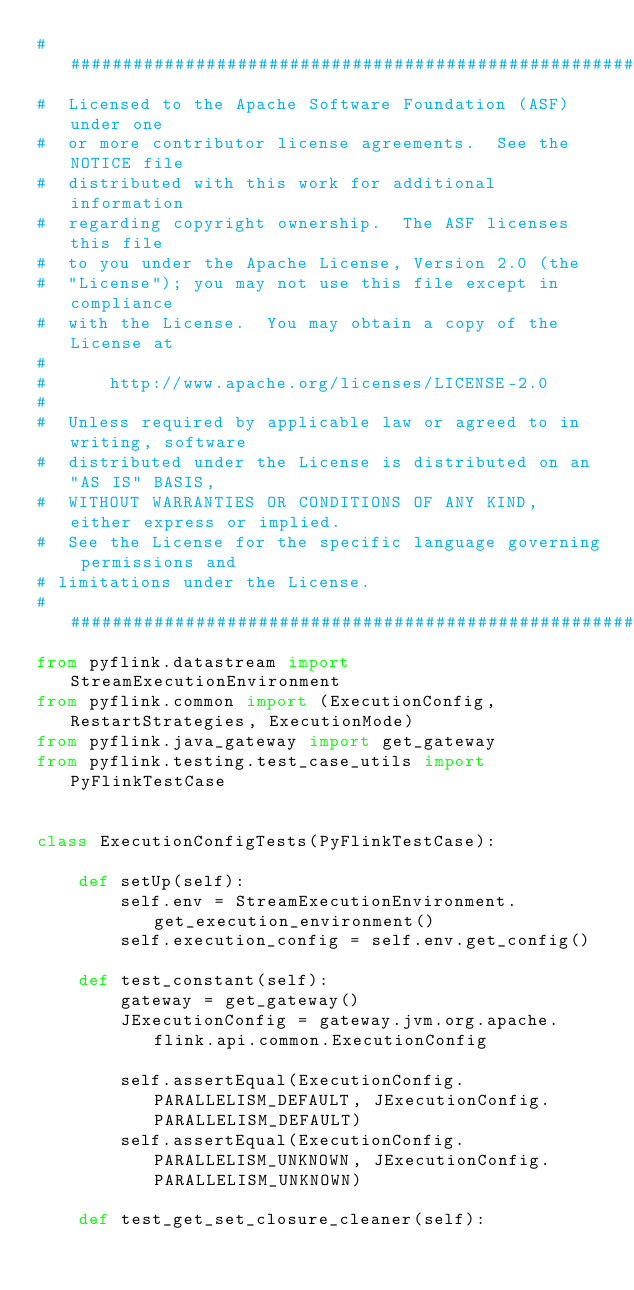Convert code to text. <code><loc_0><loc_0><loc_500><loc_500><_Python_>################################################################################
#  Licensed to the Apache Software Foundation (ASF) under one
#  or more contributor license agreements.  See the NOTICE file
#  distributed with this work for additional information
#  regarding copyright ownership.  The ASF licenses this file
#  to you under the Apache License, Version 2.0 (the
#  "License"); you may not use this file except in compliance
#  with the License.  You may obtain a copy of the License at
#
#      http://www.apache.org/licenses/LICENSE-2.0
#
#  Unless required by applicable law or agreed to in writing, software
#  distributed under the License is distributed on an "AS IS" BASIS,
#  WITHOUT WARRANTIES OR CONDITIONS OF ANY KIND, either express or implied.
#  See the License for the specific language governing permissions and
# limitations under the License.
################################################################################
from pyflink.datastream import StreamExecutionEnvironment
from pyflink.common import (ExecutionConfig, RestartStrategies, ExecutionMode)
from pyflink.java_gateway import get_gateway
from pyflink.testing.test_case_utils import PyFlinkTestCase


class ExecutionConfigTests(PyFlinkTestCase):

    def setUp(self):
        self.env = StreamExecutionEnvironment.get_execution_environment()
        self.execution_config = self.env.get_config()

    def test_constant(self):
        gateway = get_gateway()
        JExecutionConfig = gateway.jvm.org.apache.flink.api.common.ExecutionConfig

        self.assertEqual(ExecutionConfig.PARALLELISM_DEFAULT, JExecutionConfig.PARALLELISM_DEFAULT)
        self.assertEqual(ExecutionConfig.PARALLELISM_UNKNOWN, JExecutionConfig.PARALLELISM_UNKNOWN)

    def test_get_set_closure_cleaner(self):
</code> 